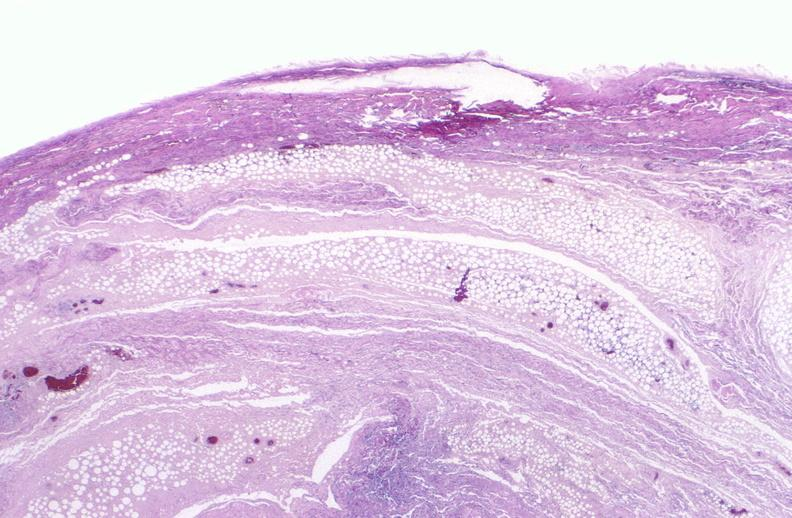does neutrophil gram positive diplococci show panniculitis and fascitis?
Answer the question using a single word or phrase. No 